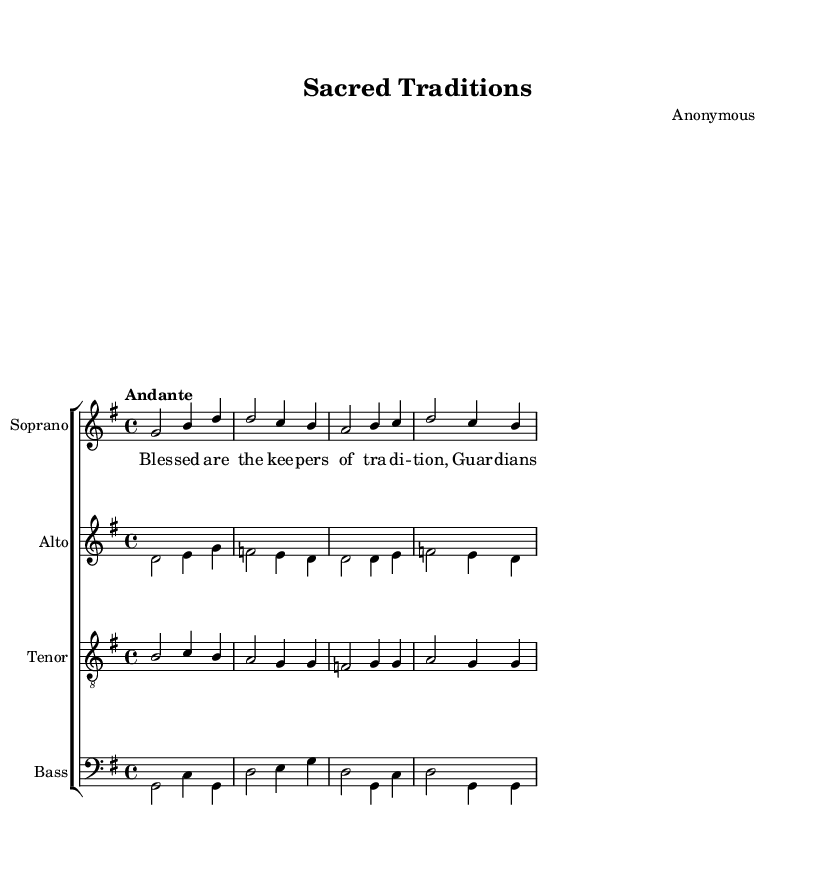What is the key signature of this music? The key signature is G major, which has one sharp (F#). This can be determined by looking at the key signature indicated at the beginning of the score.
Answer: G major What is the time signature of this music? The time signature is 4/4, as indicated at the beginning of the score. This means there are four beats in each measure and a quarter note receives one beat.
Answer: 4/4 What is the tempo marking of the piece? The tempo marking is "Andante," which indicates a moderately slow tempo. This is specifically noted in the score right below the key and time signatures.
Answer: Andante How many voices are present in this choral work? There are four voices present: Soprano, Alto, Tenor, and Bass. This can be inferred by observing the four distinct staves labeled as such in the score.
Answer: Four What is the first lyric sung by the Soprano? The first lyric sung by the Soprano is "Blessed." This can be found by referring to the lyrics aligned with the Soprano staff at the beginning of the piece.
Answer: Blessed Which voice part begins with the note B? The Tenor voice part begins with the note B. This is discerned by looking at the notes plotted on the Tenor staff, where the first note is B.
Answer: Tenor What do the lyrics "Guardians of our sacred ways" convey about the piece's theme? The lyrics convey a theme of reverence and respect for tradition and spirituality, reflecting the overarching tone of the piece aimed at praising traditional values. This interpretation can be made by analyzing the lyrical content in relation to the title "Sacred Traditions."
Answer: Reverence 